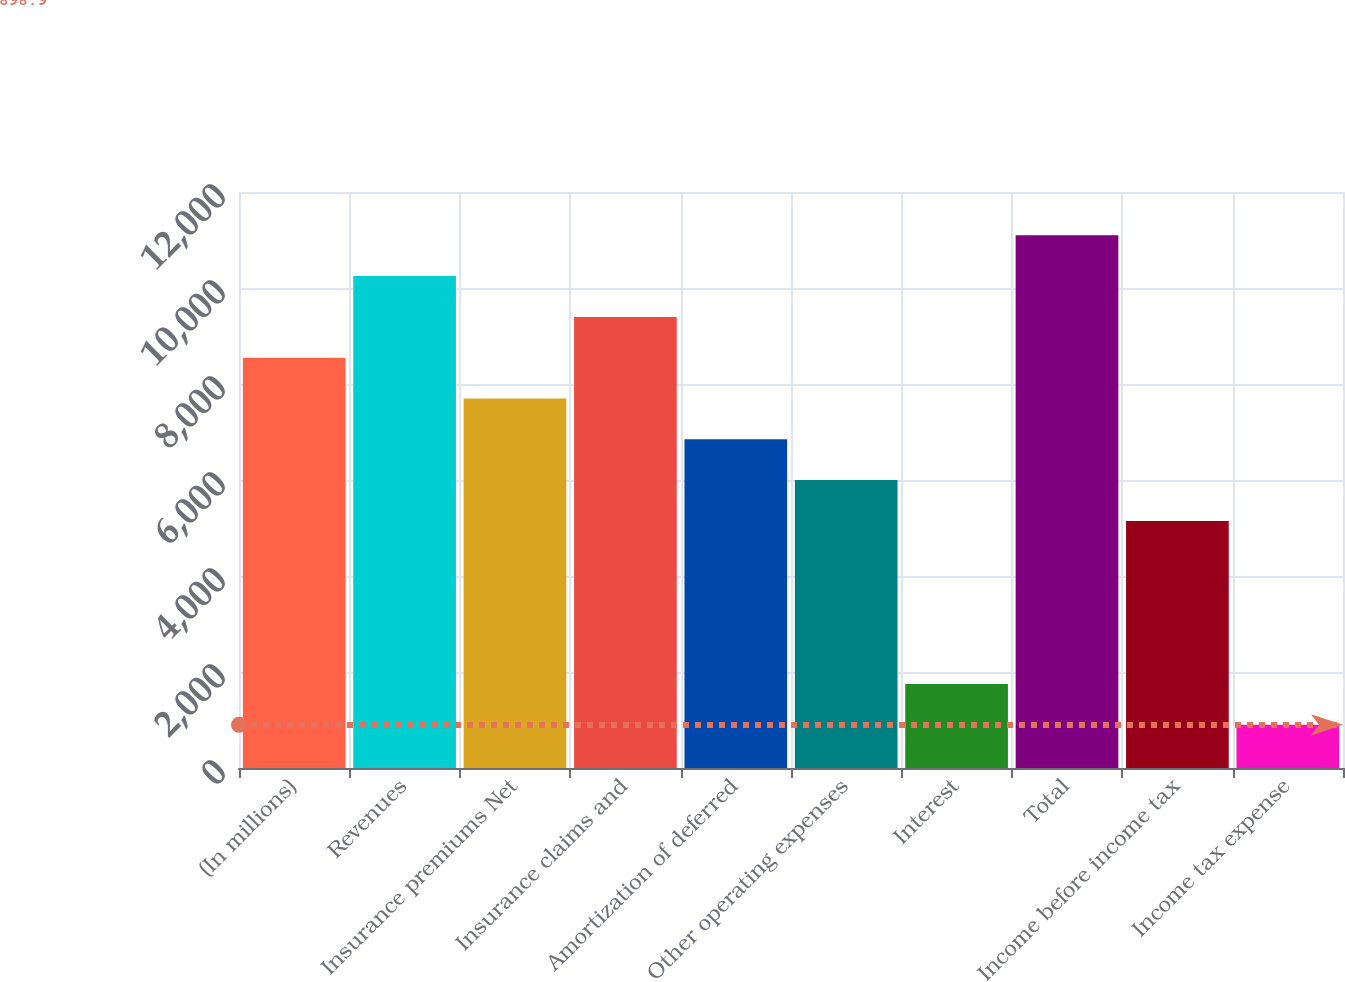<chart> <loc_0><loc_0><loc_500><loc_500><bar_chart><fcel>(In millions)<fcel>Revenues<fcel>Insurance premiums Net<fcel>Insurance claims and<fcel>Amortization of deferred<fcel>Other operating expenses<fcel>Interest<fcel>Total<fcel>Income before income tax<fcel>Income tax expense<nl><fcel>8548<fcel>10247.8<fcel>7698.1<fcel>9397.9<fcel>6848.2<fcel>5998.3<fcel>1748.8<fcel>11097.7<fcel>5148.4<fcel>898.9<nl></chart> 